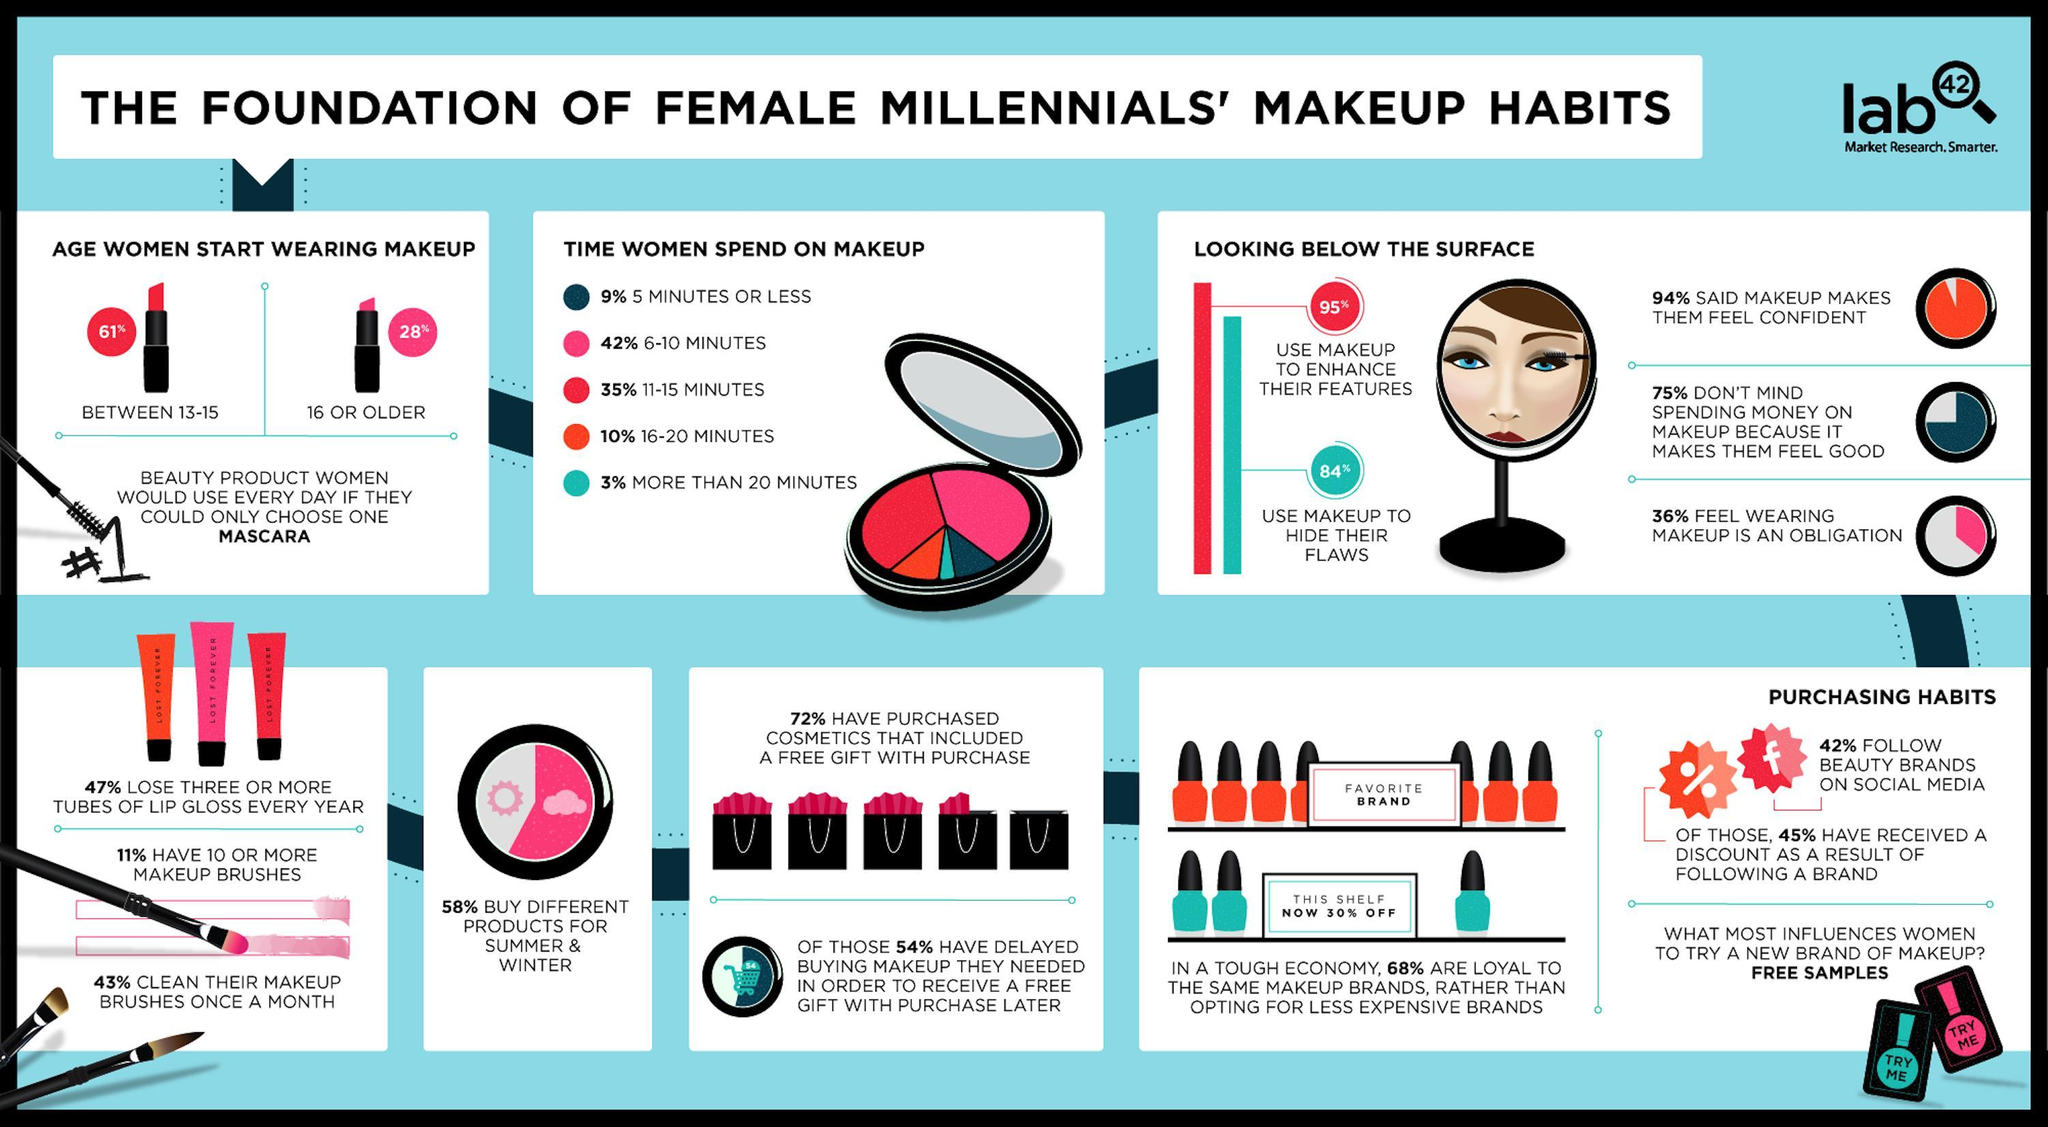What percent of millennial women do not feel that wearing makeup is an obligation as per the survey?
Answer the question with a short phrase. 64% What percent of millennial women do not follow beauty brands on social media? 58% What percent of millennial women spend 16-20 minutes on makeup? 10% What percent of millennial women use makeup to hide their flaws? 84% What percent of millennial women buy different makeup products for summer & winter? 58% 